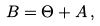Convert formula to latex. <formula><loc_0><loc_0><loc_500><loc_500>B = \Theta + A \, ,</formula> 